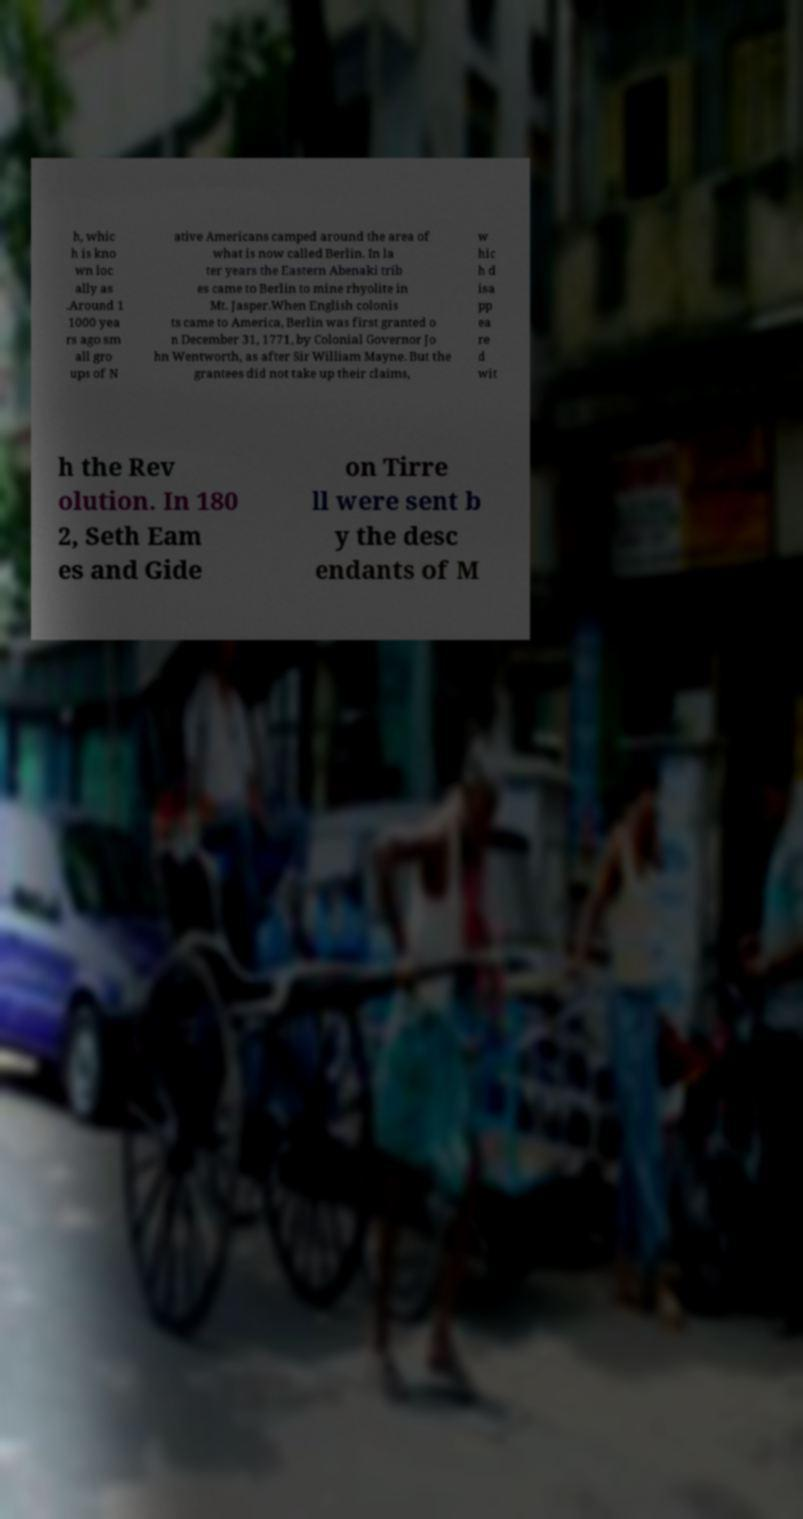For documentation purposes, I need the text within this image transcribed. Could you provide that? h, whic h is kno wn loc ally as .Around 1 1000 yea rs ago sm all gro ups of N ative Americans camped around the area of what is now called Berlin. In la ter years the Eastern Abenaki trib es came to Berlin to mine rhyolite in Mt. Jasper.When English colonis ts came to America, Berlin was first granted o n December 31, 1771, by Colonial Governor Jo hn Wentworth, as after Sir William Mayne. But the grantees did not take up their claims, w hic h d isa pp ea re d wit h the Rev olution. In 180 2, Seth Eam es and Gide on Tirre ll were sent b y the desc endants of M 